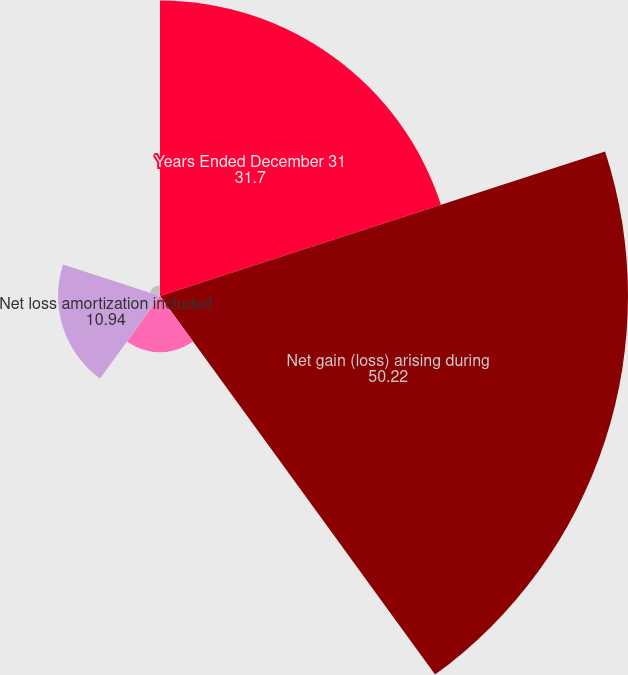<chart> <loc_0><loc_0><loc_500><loc_500><pie_chart><fcel>Years Ended December 31<fcel>Net gain (loss) arising during<fcel>Prior service credit (cost)<fcel>Net loss amortization included<fcel>Prior service (credit) cost<nl><fcel>31.7%<fcel>50.22%<fcel>6.03%<fcel>10.94%<fcel>1.12%<nl></chart> 